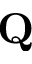Convert formula to latex. <formula><loc_0><loc_0><loc_500><loc_500>Q</formula> 